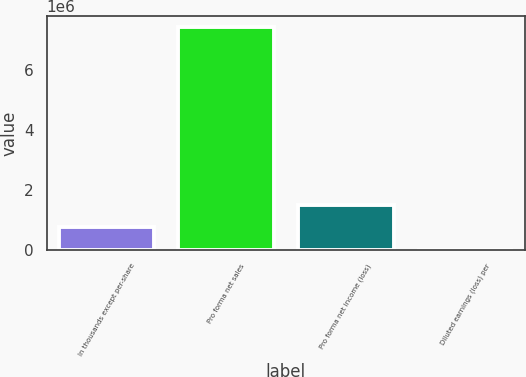<chart> <loc_0><loc_0><loc_500><loc_500><bar_chart><fcel>In thousands except per-share<fcel>Pro forma net sales<fcel>Pro forma net income (loss)<fcel>Diluted earnings (loss) per<nl><fcel>740992<fcel>7.40992e+06<fcel>1.48198e+06<fcel>0.75<nl></chart> 